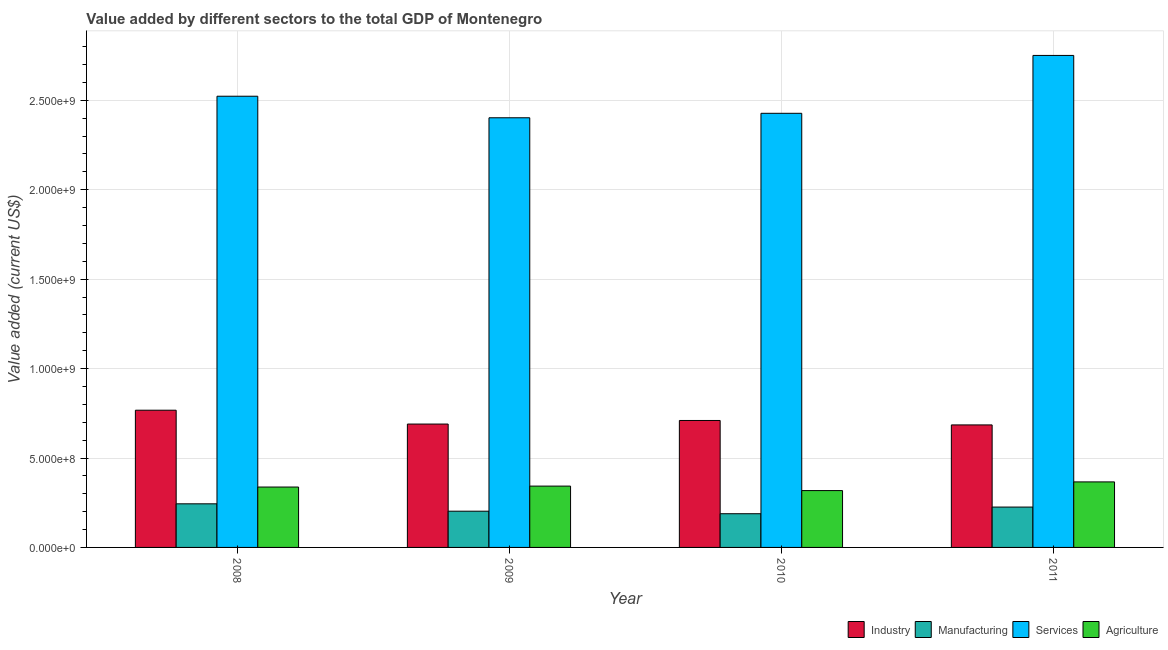How many different coloured bars are there?
Keep it short and to the point. 4. Are the number of bars on each tick of the X-axis equal?
Offer a very short reply. Yes. How many bars are there on the 4th tick from the right?
Your response must be concise. 4. In how many cases, is the number of bars for a given year not equal to the number of legend labels?
Your response must be concise. 0. What is the value added by industrial sector in 2011?
Provide a succinct answer. 6.85e+08. Across all years, what is the maximum value added by industrial sector?
Offer a very short reply. 7.67e+08. Across all years, what is the minimum value added by agricultural sector?
Offer a terse response. 3.18e+08. In which year was the value added by industrial sector maximum?
Your answer should be compact. 2008. What is the total value added by services sector in the graph?
Keep it short and to the point. 1.01e+1. What is the difference between the value added by services sector in 2008 and that in 2011?
Provide a succinct answer. -2.28e+08. What is the difference between the value added by industrial sector in 2009 and the value added by agricultural sector in 2011?
Give a very brief answer. 4.80e+06. What is the average value added by agricultural sector per year?
Offer a terse response. 3.41e+08. In the year 2009, what is the difference between the value added by industrial sector and value added by services sector?
Offer a terse response. 0. What is the ratio of the value added by industrial sector in 2009 to that in 2010?
Provide a succinct answer. 0.97. What is the difference between the highest and the second highest value added by services sector?
Offer a terse response. 2.28e+08. What is the difference between the highest and the lowest value added by manufacturing sector?
Provide a short and direct response. 5.54e+07. In how many years, is the value added by services sector greater than the average value added by services sector taken over all years?
Your response must be concise. 1. What does the 2nd bar from the left in 2008 represents?
Ensure brevity in your answer.  Manufacturing. What does the 2nd bar from the right in 2009 represents?
Ensure brevity in your answer.  Services. How many bars are there?
Offer a very short reply. 16. Are all the bars in the graph horizontal?
Offer a terse response. No. How many years are there in the graph?
Your response must be concise. 4. Are the values on the major ticks of Y-axis written in scientific E-notation?
Keep it short and to the point. Yes. Does the graph contain grids?
Your answer should be very brief. Yes. Where does the legend appear in the graph?
Give a very brief answer. Bottom right. How many legend labels are there?
Make the answer very short. 4. What is the title of the graph?
Give a very brief answer. Value added by different sectors to the total GDP of Montenegro. What is the label or title of the X-axis?
Your answer should be very brief. Year. What is the label or title of the Y-axis?
Ensure brevity in your answer.  Value added (current US$). What is the Value added (current US$) in Industry in 2008?
Offer a terse response. 7.67e+08. What is the Value added (current US$) in Manufacturing in 2008?
Your response must be concise. 2.44e+08. What is the Value added (current US$) of Services in 2008?
Your answer should be very brief. 2.52e+09. What is the Value added (current US$) of Agriculture in 2008?
Your answer should be compact. 3.38e+08. What is the Value added (current US$) of Industry in 2009?
Your response must be concise. 6.90e+08. What is the Value added (current US$) in Manufacturing in 2009?
Your answer should be very brief. 2.03e+08. What is the Value added (current US$) in Services in 2009?
Offer a terse response. 2.40e+09. What is the Value added (current US$) in Agriculture in 2009?
Give a very brief answer. 3.43e+08. What is the Value added (current US$) in Industry in 2010?
Make the answer very short. 7.10e+08. What is the Value added (current US$) of Manufacturing in 2010?
Offer a very short reply. 1.88e+08. What is the Value added (current US$) in Services in 2010?
Your answer should be compact. 2.43e+09. What is the Value added (current US$) in Agriculture in 2010?
Keep it short and to the point. 3.18e+08. What is the Value added (current US$) of Industry in 2011?
Ensure brevity in your answer.  6.85e+08. What is the Value added (current US$) in Manufacturing in 2011?
Provide a succinct answer. 2.26e+08. What is the Value added (current US$) of Services in 2011?
Provide a short and direct response. 2.75e+09. What is the Value added (current US$) in Agriculture in 2011?
Give a very brief answer. 3.66e+08. Across all years, what is the maximum Value added (current US$) in Industry?
Ensure brevity in your answer.  7.67e+08. Across all years, what is the maximum Value added (current US$) of Manufacturing?
Offer a very short reply. 2.44e+08. Across all years, what is the maximum Value added (current US$) of Services?
Your answer should be very brief. 2.75e+09. Across all years, what is the maximum Value added (current US$) in Agriculture?
Give a very brief answer. 3.66e+08. Across all years, what is the minimum Value added (current US$) of Industry?
Give a very brief answer. 6.85e+08. Across all years, what is the minimum Value added (current US$) in Manufacturing?
Provide a succinct answer. 1.88e+08. Across all years, what is the minimum Value added (current US$) of Services?
Offer a very short reply. 2.40e+09. Across all years, what is the minimum Value added (current US$) of Agriculture?
Offer a very short reply. 3.18e+08. What is the total Value added (current US$) in Industry in the graph?
Your answer should be very brief. 2.85e+09. What is the total Value added (current US$) in Manufacturing in the graph?
Offer a terse response. 8.60e+08. What is the total Value added (current US$) of Services in the graph?
Give a very brief answer. 1.01e+1. What is the total Value added (current US$) of Agriculture in the graph?
Offer a terse response. 1.36e+09. What is the difference between the Value added (current US$) of Industry in 2008 and that in 2009?
Offer a very short reply. 7.74e+07. What is the difference between the Value added (current US$) of Manufacturing in 2008 and that in 2009?
Ensure brevity in your answer.  4.13e+07. What is the difference between the Value added (current US$) in Services in 2008 and that in 2009?
Provide a succinct answer. 1.20e+08. What is the difference between the Value added (current US$) of Agriculture in 2008 and that in 2009?
Offer a very short reply. -5.26e+06. What is the difference between the Value added (current US$) of Industry in 2008 and that in 2010?
Your response must be concise. 5.74e+07. What is the difference between the Value added (current US$) in Manufacturing in 2008 and that in 2010?
Provide a succinct answer. 5.54e+07. What is the difference between the Value added (current US$) in Services in 2008 and that in 2010?
Ensure brevity in your answer.  9.55e+07. What is the difference between the Value added (current US$) of Agriculture in 2008 and that in 2010?
Provide a short and direct response. 1.98e+07. What is the difference between the Value added (current US$) in Industry in 2008 and that in 2011?
Your response must be concise. 8.22e+07. What is the difference between the Value added (current US$) in Manufacturing in 2008 and that in 2011?
Offer a terse response. 1.82e+07. What is the difference between the Value added (current US$) in Services in 2008 and that in 2011?
Make the answer very short. -2.28e+08. What is the difference between the Value added (current US$) of Agriculture in 2008 and that in 2011?
Offer a terse response. -2.87e+07. What is the difference between the Value added (current US$) of Industry in 2009 and that in 2010?
Provide a short and direct response. -2.00e+07. What is the difference between the Value added (current US$) in Manufacturing in 2009 and that in 2010?
Make the answer very short. 1.41e+07. What is the difference between the Value added (current US$) in Services in 2009 and that in 2010?
Your answer should be very brief. -2.50e+07. What is the difference between the Value added (current US$) in Agriculture in 2009 and that in 2010?
Provide a succinct answer. 2.51e+07. What is the difference between the Value added (current US$) in Industry in 2009 and that in 2011?
Your response must be concise. 4.80e+06. What is the difference between the Value added (current US$) of Manufacturing in 2009 and that in 2011?
Your answer should be very brief. -2.31e+07. What is the difference between the Value added (current US$) of Services in 2009 and that in 2011?
Make the answer very short. -3.49e+08. What is the difference between the Value added (current US$) of Agriculture in 2009 and that in 2011?
Keep it short and to the point. -2.35e+07. What is the difference between the Value added (current US$) in Industry in 2010 and that in 2011?
Make the answer very short. 2.48e+07. What is the difference between the Value added (current US$) of Manufacturing in 2010 and that in 2011?
Your answer should be very brief. -3.72e+07. What is the difference between the Value added (current US$) in Services in 2010 and that in 2011?
Ensure brevity in your answer.  -3.24e+08. What is the difference between the Value added (current US$) in Agriculture in 2010 and that in 2011?
Your answer should be compact. -4.86e+07. What is the difference between the Value added (current US$) in Industry in 2008 and the Value added (current US$) in Manufacturing in 2009?
Your response must be concise. 5.65e+08. What is the difference between the Value added (current US$) of Industry in 2008 and the Value added (current US$) of Services in 2009?
Offer a terse response. -1.64e+09. What is the difference between the Value added (current US$) of Industry in 2008 and the Value added (current US$) of Agriculture in 2009?
Give a very brief answer. 4.24e+08. What is the difference between the Value added (current US$) of Manufacturing in 2008 and the Value added (current US$) of Services in 2009?
Give a very brief answer. -2.16e+09. What is the difference between the Value added (current US$) in Manufacturing in 2008 and the Value added (current US$) in Agriculture in 2009?
Keep it short and to the point. -9.90e+07. What is the difference between the Value added (current US$) of Services in 2008 and the Value added (current US$) of Agriculture in 2009?
Provide a short and direct response. 2.18e+09. What is the difference between the Value added (current US$) in Industry in 2008 and the Value added (current US$) in Manufacturing in 2010?
Give a very brief answer. 5.79e+08. What is the difference between the Value added (current US$) in Industry in 2008 and the Value added (current US$) in Services in 2010?
Your answer should be very brief. -1.66e+09. What is the difference between the Value added (current US$) of Industry in 2008 and the Value added (current US$) of Agriculture in 2010?
Give a very brief answer. 4.49e+08. What is the difference between the Value added (current US$) in Manufacturing in 2008 and the Value added (current US$) in Services in 2010?
Offer a very short reply. -2.18e+09. What is the difference between the Value added (current US$) in Manufacturing in 2008 and the Value added (current US$) in Agriculture in 2010?
Keep it short and to the point. -7.40e+07. What is the difference between the Value added (current US$) of Services in 2008 and the Value added (current US$) of Agriculture in 2010?
Offer a terse response. 2.21e+09. What is the difference between the Value added (current US$) of Industry in 2008 and the Value added (current US$) of Manufacturing in 2011?
Your answer should be compact. 5.42e+08. What is the difference between the Value added (current US$) in Industry in 2008 and the Value added (current US$) in Services in 2011?
Your response must be concise. -1.98e+09. What is the difference between the Value added (current US$) of Industry in 2008 and the Value added (current US$) of Agriculture in 2011?
Ensure brevity in your answer.  4.01e+08. What is the difference between the Value added (current US$) in Manufacturing in 2008 and the Value added (current US$) in Services in 2011?
Provide a short and direct response. -2.51e+09. What is the difference between the Value added (current US$) of Manufacturing in 2008 and the Value added (current US$) of Agriculture in 2011?
Keep it short and to the point. -1.23e+08. What is the difference between the Value added (current US$) of Services in 2008 and the Value added (current US$) of Agriculture in 2011?
Offer a very short reply. 2.16e+09. What is the difference between the Value added (current US$) in Industry in 2009 and the Value added (current US$) in Manufacturing in 2010?
Ensure brevity in your answer.  5.01e+08. What is the difference between the Value added (current US$) in Industry in 2009 and the Value added (current US$) in Services in 2010?
Your answer should be very brief. -1.74e+09. What is the difference between the Value added (current US$) in Industry in 2009 and the Value added (current US$) in Agriculture in 2010?
Your response must be concise. 3.72e+08. What is the difference between the Value added (current US$) of Manufacturing in 2009 and the Value added (current US$) of Services in 2010?
Provide a succinct answer. -2.22e+09. What is the difference between the Value added (current US$) of Manufacturing in 2009 and the Value added (current US$) of Agriculture in 2010?
Your answer should be compact. -1.15e+08. What is the difference between the Value added (current US$) of Services in 2009 and the Value added (current US$) of Agriculture in 2010?
Ensure brevity in your answer.  2.08e+09. What is the difference between the Value added (current US$) in Industry in 2009 and the Value added (current US$) in Manufacturing in 2011?
Provide a succinct answer. 4.64e+08. What is the difference between the Value added (current US$) in Industry in 2009 and the Value added (current US$) in Services in 2011?
Ensure brevity in your answer.  -2.06e+09. What is the difference between the Value added (current US$) of Industry in 2009 and the Value added (current US$) of Agriculture in 2011?
Offer a very short reply. 3.23e+08. What is the difference between the Value added (current US$) in Manufacturing in 2009 and the Value added (current US$) in Services in 2011?
Provide a short and direct response. -2.55e+09. What is the difference between the Value added (current US$) in Manufacturing in 2009 and the Value added (current US$) in Agriculture in 2011?
Your answer should be compact. -1.64e+08. What is the difference between the Value added (current US$) of Services in 2009 and the Value added (current US$) of Agriculture in 2011?
Your response must be concise. 2.04e+09. What is the difference between the Value added (current US$) in Industry in 2010 and the Value added (current US$) in Manufacturing in 2011?
Your answer should be very brief. 4.84e+08. What is the difference between the Value added (current US$) in Industry in 2010 and the Value added (current US$) in Services in 2011?
Make the answer very short. -2.04e+09. What is the difference between the Value added (current US$) in Industry in 2010 and the Value added (current US$) in Agriculture in 2011?
Provide a short and direct response. 3.43e+08. What is the difference between the Value added (current US$) of Manufacturing in 2010 and the Value added (current US$) of Services in 2011?
Give a very brief answer. -2.56e+09. What is the difference between the Value added (current US$) in Manufacturing in 2010 and the Value added (current US$) in Agriculture in 2011?
Offer a terse response. -1.78e+08. What is the difference between the Value added (current US$) of Services in 2010 and the Value added (current US$) of Agriculture in 2011?
Keep it short and to the point. 2.06e+09. What is the average Value added (current US$) in Industry per year?
Your answer should be compact. 7.13e+08. What is the average Value added (current US$) of Manufacturing per year?
Offer a very short reply. 2.15e+08. What is the average Value added (current US$) in Services per year?
Ensure brevity in your answer.  2.53e+09. What is the average Value added (current US$) in Agriculture per year?
Offer a terse response. 3.41e+08. In the year 2008, what is the difference between the Value added (current US$) in Industry and Value added (current US$) in Manufacturing?
Provide a succinct answer. 5.23e+08. In the year 2008, what is the difference between the Value added (current US$) in Industry and Value added (current US$) in Services?
Offer a very short reply. -1.76e+09. In the year 2008, what is the difference between the Value added (current US$) in Industry and Value added (current US$) in Agriculture?
Your response must be concise. 4.30e+08. In the year 2008, what is the difference between the Value added (current US$) in Manufacturing and Value added (current US$) in Services?
Make the answer very short. -2.28e+09. In the year 2008, what is the difference between the Value added (current US$) in Manufacturing and Value added (current US$) in Agriculture?
Your answer should be compact. -9.38e+07. In the year 2008, what is the difference between the Value added (current US$) in Services and Value added (current US$) in Agriculture?
Provide a succinct answer. 2.19e+09. In the year 2009, what is the difference between the Value added (current US$) in Industry and Value added (current US$) in Manufacturing?
Offer a terse response. 4.87e+08. In the year 2009, what is the difference between the Value added (current US$) of Industry and Value added (current US$) of Services?
Ensure brevity in your answer.  -1.71e+09. In the year 2009, what is the difference between the Value added (current US$) of Industry and Value added (current US$) of Agriculture?
Offer a very short reply. 3.47e+08. In the year 2009, what is the difference between the Value added (current US$) of Manufacturing and Value added (current US$) of Services?
Offer a very short reply. -2.20e+09. In the year 2009, what is the difference between the Value added (current US$) of Manufacturing and Value added (current US$) of Agriculture?
Your answer should be very brief. -1.40e+08. In the year 2009, what is the difference between the Value added (current US$) of Services and Value added (current US$) of Agriculture?
Keep it short and to the point. 2.06e+09. In the year 2010, what is the difference between the Value added (current US$) of Industry and Value added (current US$) of Manufacturing?
Ensure brevity in your answer.  5.21e+08. In the year 2010, what is the difference between the Value added (current US$) in Industry and Value added (current US$) in Services?
Ensure brevity in your answer.  -1.72e+09. In the year 2010, what is the difference between the Value added (current US$) in Industry and Value added (current US$) in Agriculture?
Keep it short and to the point. 3.92e+08. In the year 2010, what is the difference between the Value added (current US$) of Manufacturing and Value added (current US$) of Services?
Your response must be concise. -2.24e+09. In the year 2010, what is the difference between the Value added (current US$) in Manufacturing and Value added (current US$) in Agriculture?
Your answer should be very brief. -1.29e+08. In the year 2010, what is the difference between the Value added (current US$) of Services and Value added (current US$) of Agriculture?
Give a very brief answer. 2.11e+09. In the year 2011, what is the difference between the Value added (current US$) in Industry and Value added (current US$) in Manufacturing?
Your answer should be compact. 4.59e+08. In the year 2011, what is the difference between the Value added (current US$) of Industry and Value added (current US$) of Services?
Provide a short and direct response. -2.07e+09. In the year 2011, what is the difference between the Value added (current US$) of Industry and Value added (current US$) of Agriculture?
Keep it short and to the point. 3.19e+08. In the year 2011, what is the difference between the Value added (current US$) in Manufacturing and Value added (current US$) in Services?
Offer a terse response. -2.53e+09. In the year 2011, what is the difference between the Value added (current US$) of Manufacturing and Value added (current US$) of Agriculture?
Give a very brief answer. -1.41e+08. In the year 2011, what is the difference between the Value added (current US$) in Services and Value added (current US$) in Agriculture?
Provide a succinct answer. 2.38e+09. What is the ratio of the Value added (current US$) in Industry in 2008 to that in 2009?
Keep it short and to the point. 1.11. What is the ratio of the Value added (current US$) in Manufacturing in 2008 to that in 2009?
Offer a terse response. 1.2. What is the ratio of the Value added (current US$) in Services in 2008 to that in 2009?
Give a very brief answer. 1.05. What is the ratio of the Value added (current US$) of Agriculture in 2008 to that in 2009?
Provide a succinct answer. 0.98. What is the ratio of the Value added (current US$) of Industry in 2008 to that in 2010?
Provide a succinct answer. 1.08. What is the ratio of the Value added (current US$) in Manufacturing in 2008 to that in 2010?
Offer a very short reply. 1.29. What is the ratio of the Value added (current US$) of Services in 2008 to that in 2010?
Your answer should be very brief. 1.04. What is the ratio of the Value added (current US$) of Agriculture in 2008 to that in 2010?
Ensure brevity in your answer.  1.06. What is the ratio of the Value added (current US$) of Industry in 2008 to that in 2011?
Offer a very short reply. 1.12. What is the ratio of the Value added (current US$) of Manufacturing in 2008 to that in 2011?
Ensure brevity in your answer.  1.08. What is the ratio of the Value added (current US$) in Services in 2008 to that in 2011?
Offer a very short reply. 0.92. What is the ratio of the Value added (current US$) of Agriculture in 2008 to that in 2011?
Provide a short and direct response. 0.92. What is the ratio of the Value added (current US$) of Industry in 2009 to that in 2010?
Make the answer very short. 0.97. What is the ratio of the Value added (current US$) of Manufacturing in 2009 to that in 2010?
Provide a succinct answer. 1.07. What is the ratio of the Value added (current US$) of Agriculture in 2009 to that in 2010?
Offer a terse response. 1.08. What is the ratio of the Value added (current US$) of Manufacturing in 2009 to that in 2011?
Give a very brief answer. 0.9. What is the ratio of the Value added (current US$) of Services in 2009 to that in 2011?
Your response must be concise. 0.87. What is the ratio of the Value added (current US$) of Agriculture in 2009 to that in 2011?
Make the answer very short. 0.94. What is the ratio of the Value added (current US$) of Industry in 2010 to that in 2011?
Provide a short and direct response. 1.04. What is the ratio of the Value added (current US$) of Manufacturing in 2010 to that in 2011?
Make the answer very short. 0.84. What is the ratio of the Value added (current US$) in Services in 2010 to that in 2011?
Provide a short and direct response. 0.88. What is the ratio of the Value added (current US$) of Agriculture in 2010 to that in 2011?
Ensure brevity in your answer.  0.87. What is the difference between the highest and the second highest Value added (current US$) of Industry?
Make the answer very short. 5.74e+07. What is the difference between the highest and the second highest Value added (current US$) in Manufacturing?
Make the answer very short. 1.82e+07. What is the difference between the highest and the second highest Value added (current US$) of Services?
Offer a very short reply. 2.28e+08. What is the difference between the highest and the second highest Value added (current US$) of Agriculture?
Provide a succinct answer. 2.35e+07. What is the difference between the highest and the lowest Value added (current US$) of Industry?
Your answer should be very brief. 8.22e+07. What is the difference between the highest and the lowest Value added (current US$) in Manufacturing?
Provide a succinct answer. 5.54e+07. What is the difference between the highest and the lowest Value added (current US$) in Services?
Your answer should be very brief. 3.49e+08. What is the difference between the highest and the lowest Value added (current US$) of Agriculture?
Give a very brief answer. 4.86e+07. 